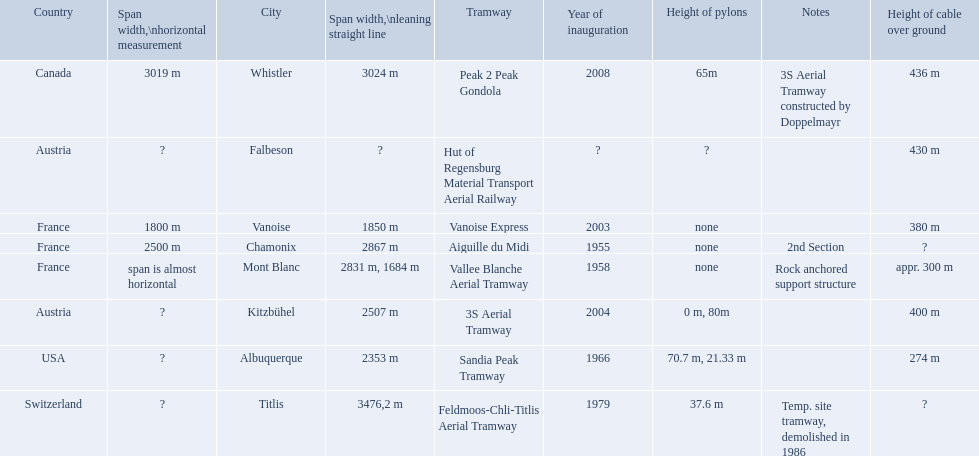What are all of the tramways? Peak 2 Peak Gondola, Hut of Regensburg Material Transport Aerial Railway, Vanoise Express, Aiguille du Midi, Vallee Blanche Aerial Tramway, 3S Aerial Tramway, Sandia Peak Tramway, Feldmoos-Chli-Titlis Aerial Tramway. When were they inaugurated? 2008, ?, 2003, 1955, 1958, 2004, 1966, 1979. Now, between 3s aerial tramway and aiguille du midi, which was inaugurated first? Aiguille du Midi. 